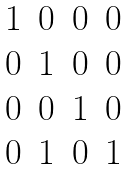<formula> <loc_0><loc_0><loc_500><loc_500>\begin{matrix} 1 & 0 & 0 & 0 \\ 0 & 1 & 0 & 0 \\ 0 & 0 & 1 & 0 \\ 0 & 1 & 0 & 1 \\ \end{matrix}</formula> 